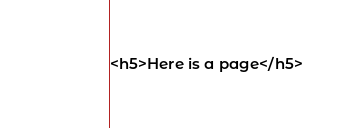<code> <loc_0><loc_0><loc_500><loc_500><_HTML_><h5>Here is a page</h5></code> 